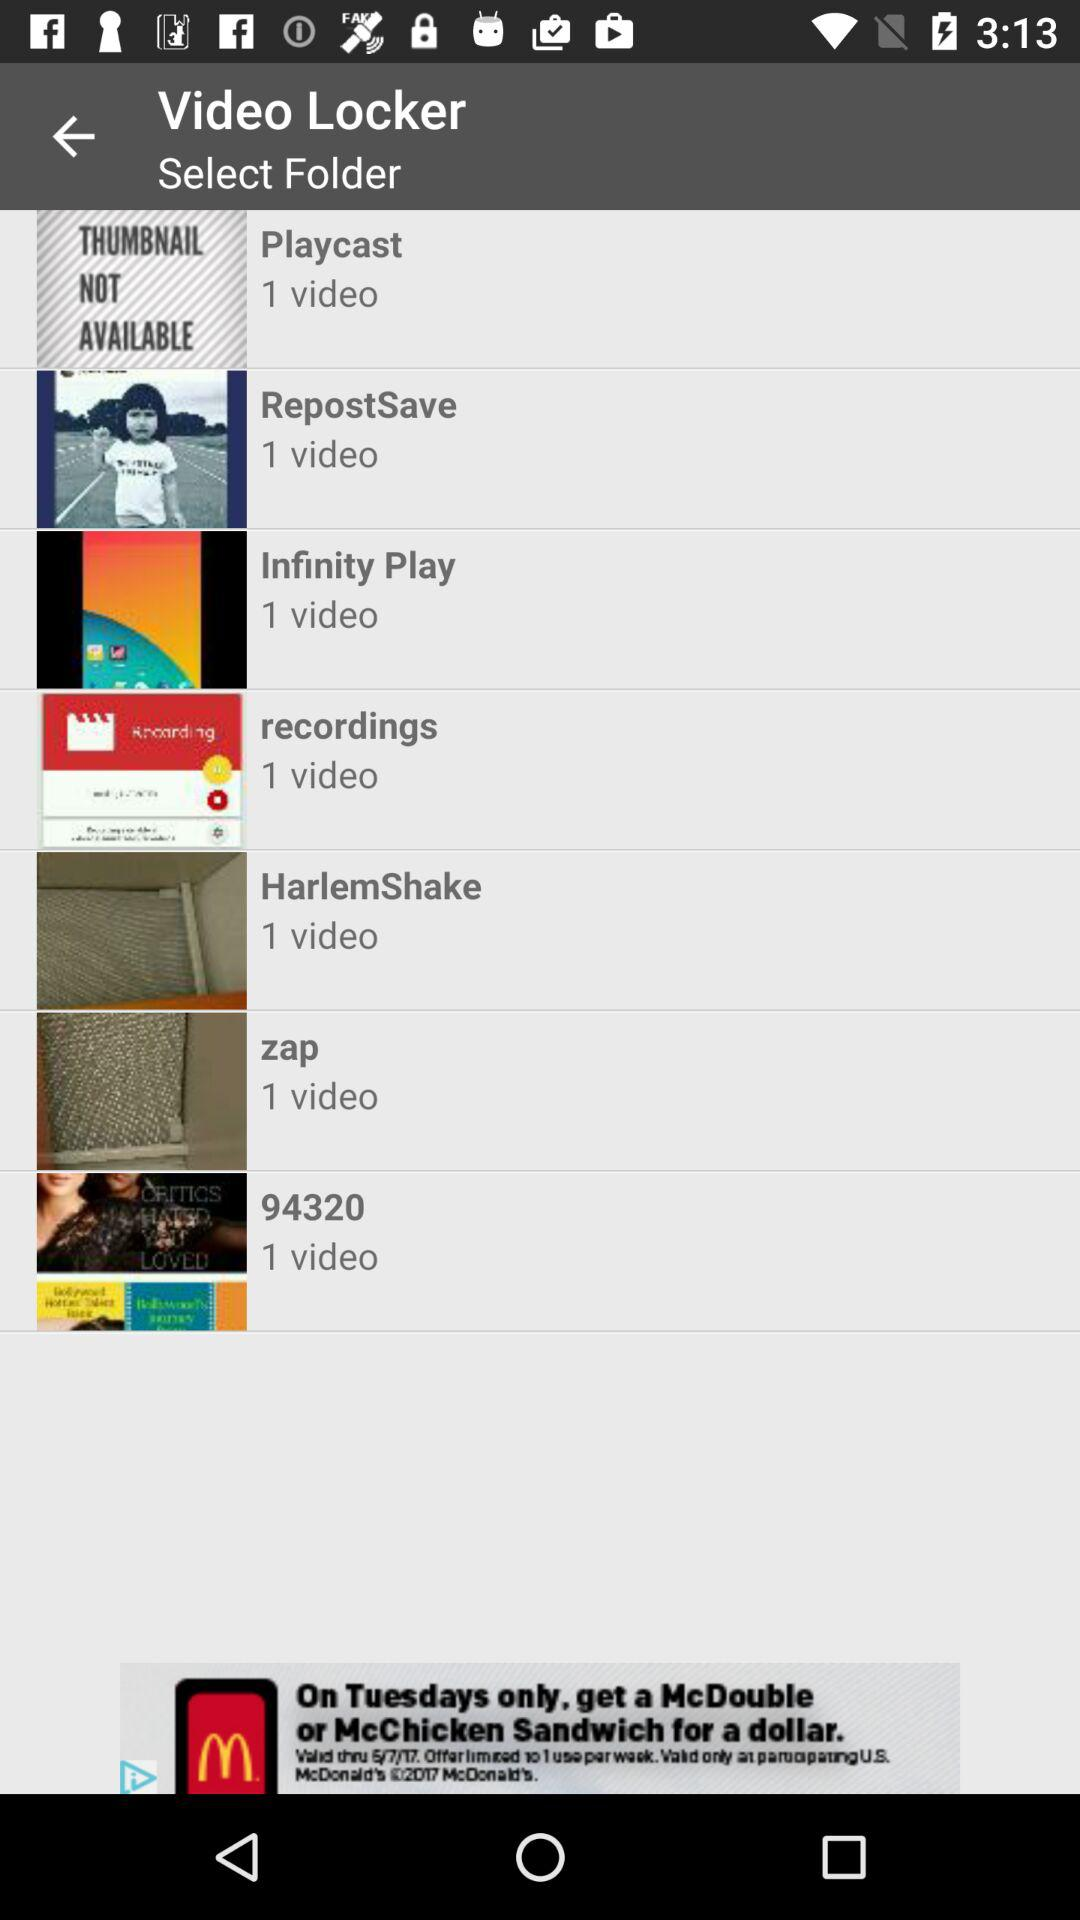What is the number of videos in the recording folder? There is 1 video in the recording folder. 